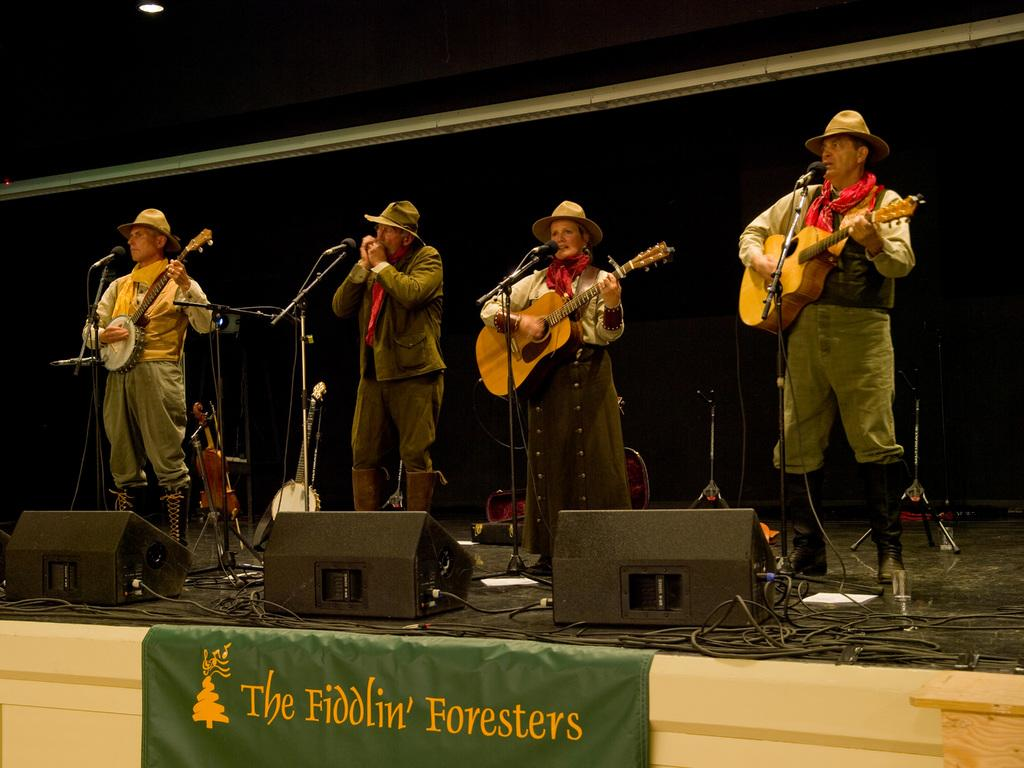How many people are present in the image? There are four people in the image. What are the people doing in the image? The people are playing musical instruments. Can you describe the setting in which the people are playing their instruments? The people are standing in front of a mic. What type of star can be seen in the image? There is no star present in the image; it features four people playing musical instruments in front of a mic. 